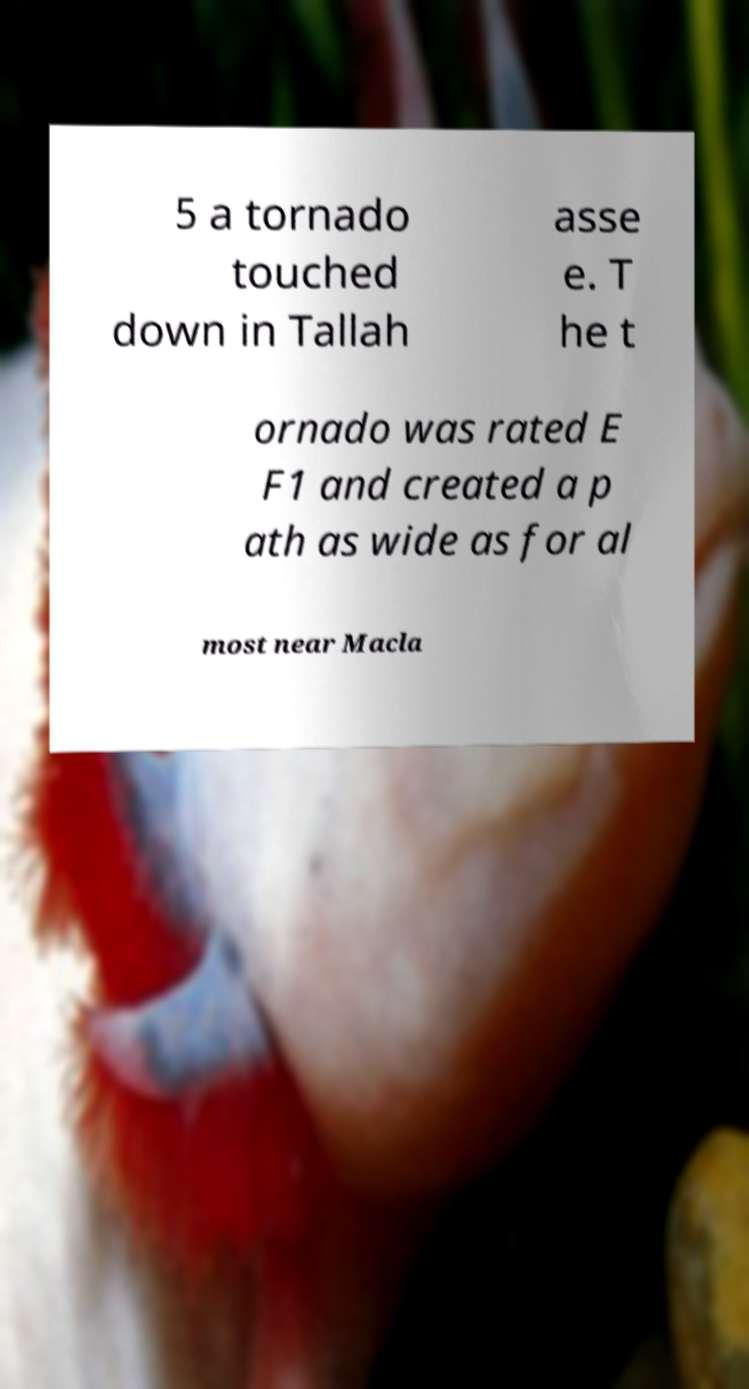There's text embedded in this image that I need extracted. Can you transcribe it verbatim? 5 a tornado touched down in Tallah asse e. T he t ornado was rated E F1 and created a p ath as wide as for al most near Macla 